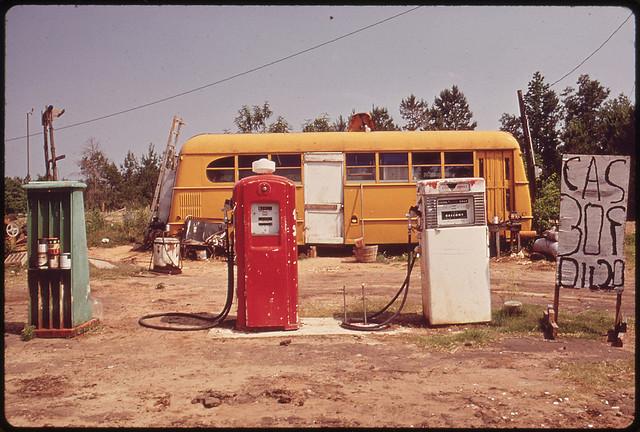Why is there a yellow bus off to the side?
Answer briefly. Yes. What kind of business is this?
Write a very short answer. Gas station. What vehicle is in the background?
Write a very short answer. Bus. 